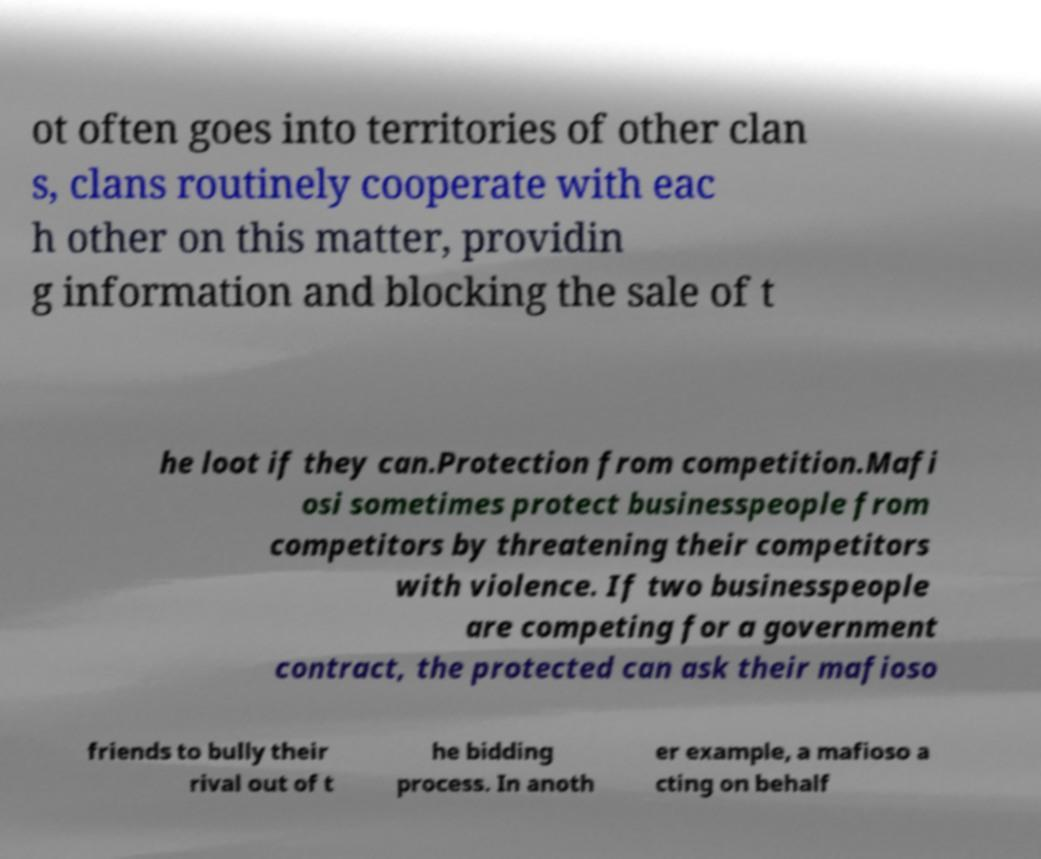Can you accurately transcribe the text from the provided image for me? ot often goes into territories of other clan s, clans routinely cooperate with eac h other on this matter, providin g information and blocking the sale of t he loot if they can.Protection from competition.Mafi osi sometimes protect businesspeople from competitors by threatening their competitors with violence. If two businesspeople are competing for a government contract, the protected can ask their mafioso friends to bully their rival out of t he bidding process. In anoth er example, a mafioso a cting on behalf 